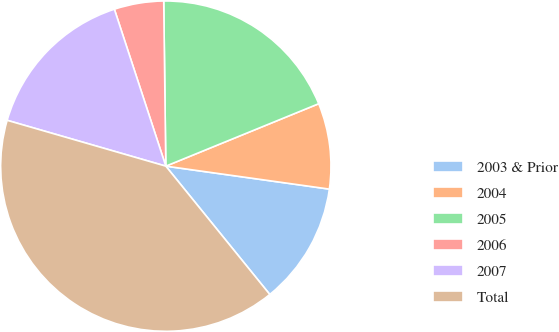Convert chart. <chart><loc_0><loc_0><loc_500><loc_500><pie_chart><fcel>2003 & Prior<fcel>2004<fcel>2005<fcel>2006<fcel>2007<fcel>Total<nl><fcel>11.94%<fcel>8.39%<fcel>19.03%<fcel>4.84%<fcel>15.48%<fcel>40.31%<nl></chart> 